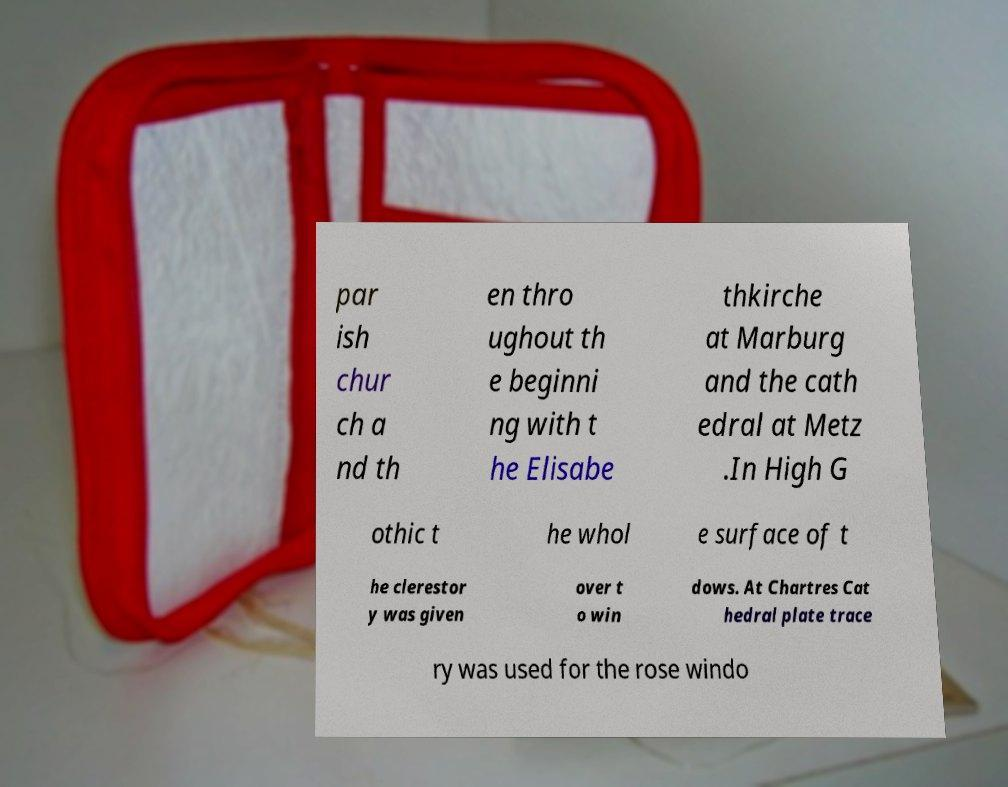Could you assist in decoding the text presented in this image and type it out clearly? par ish chur ch a nd th en thro ughout th e beginni ng with t he Elisabe thkirche at Marburg and the cath edral at Metz .In High G othic t he whol e surface of t he clerestor y was given over t o win dows. At Chartres Cat hedral plate trace ry was used for the rose windo 